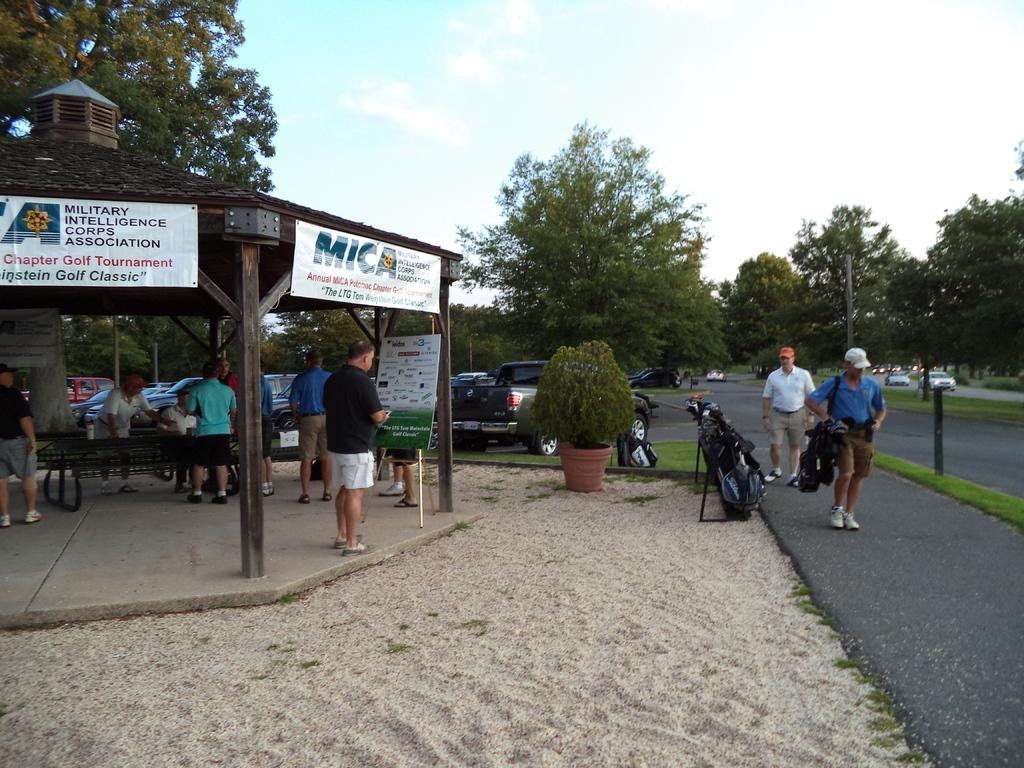How many people are in the image? There are people in the image, but the exact number is not specified. What type of structure can be seen in the image? There is a shed in the image. What type of terrain is visible in the image? There is sand in the image. What type of decorations are present in the image? There are posters in the image. What type of vegetation is present in the image? There is a plant and trees in the image. What type of vehicles are present in the image? There are vehicles in the image. What type of objects are present in the image? There are some objects in the image. What can be seen in the background of the image? The sky is visible in the background of the image. What type of ray is attacking the people in the image? There is no ray present in the image, and therefore no such attack can be observed. What type of pain is the plant experiencing in the image? There is no indication of pain in the image, and plants do not experience pain as humans do. 